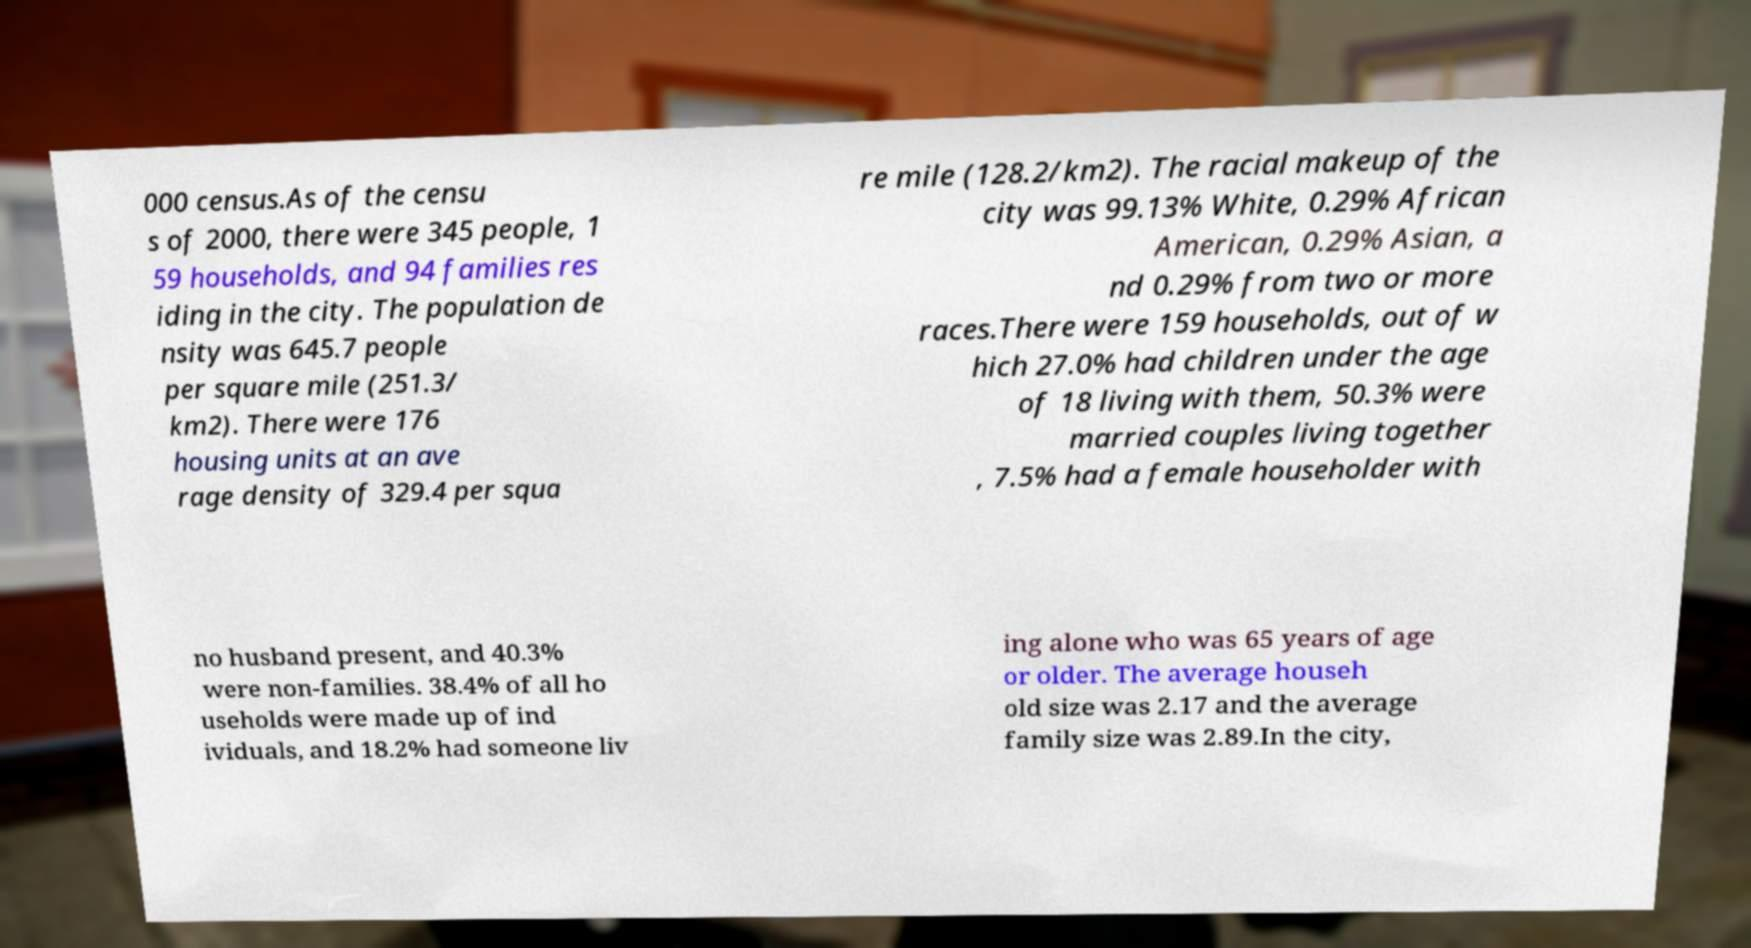Can you read and provide the text displayed in the image?This photo seems to have some interesting text. Can you extract and type it out for me? 000 census.As of the censu s of 2000, there were 345 people, 1 59 households, and 94 families res iding in the city. The population de nsity was 645.7 people per square mile (251.3/ km2). There were 176 housing units at an ave rage density of 329.4 per squa re mile (128.2/km2). The racial makeup of the city was 99.13% White, 0.29% African American, 0.29% Asian, a nd 0.29% from two or more races.There were 159 households, out of w hich 27.0% had children under the age of 18 living with them, 50.3% were married couples living together , 7.5% had a female householder with no husband present, and 40.3% were non-families. 38.4% of all ho useholds were made up of ind ividuals, and 18.2% had someone liv ing alone who was 65 years of age or older. The average househ old size was 2.17 and the average family size was 2.89.In the city, 